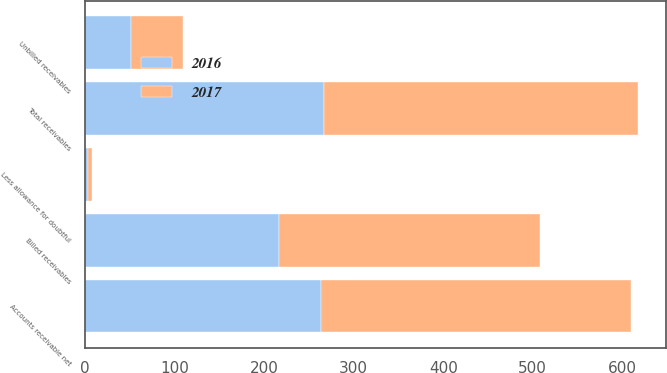<chart> <loc_0><loc_0><loc_500><loc_500><stacked_bar_chart><ecel><fcel>Billed receivables<fcel>Unbilled receivables<fcel>Total receivables<fcel>Less allowance for doubtful<fcel>Accounts receivable net<nl><fcel>2017<fcel>291.4<fcel>58.7<fcel>350.1<fcel>4.6<fcel>345.5<nl><fcel>2016<fcel>216.4<fcel>50.9<fcel>267.3<fcel>3.4<fcel>263.9<nl></chart> 